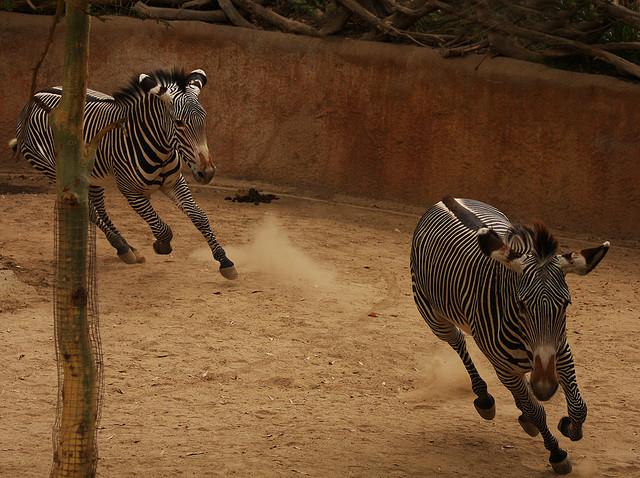Where are the zebras?
Answer briefly. Zoo. Could one Zebra be aggressive?
Short answer required. Yes. What are the zebras doing?
Keep it brief. Running. 